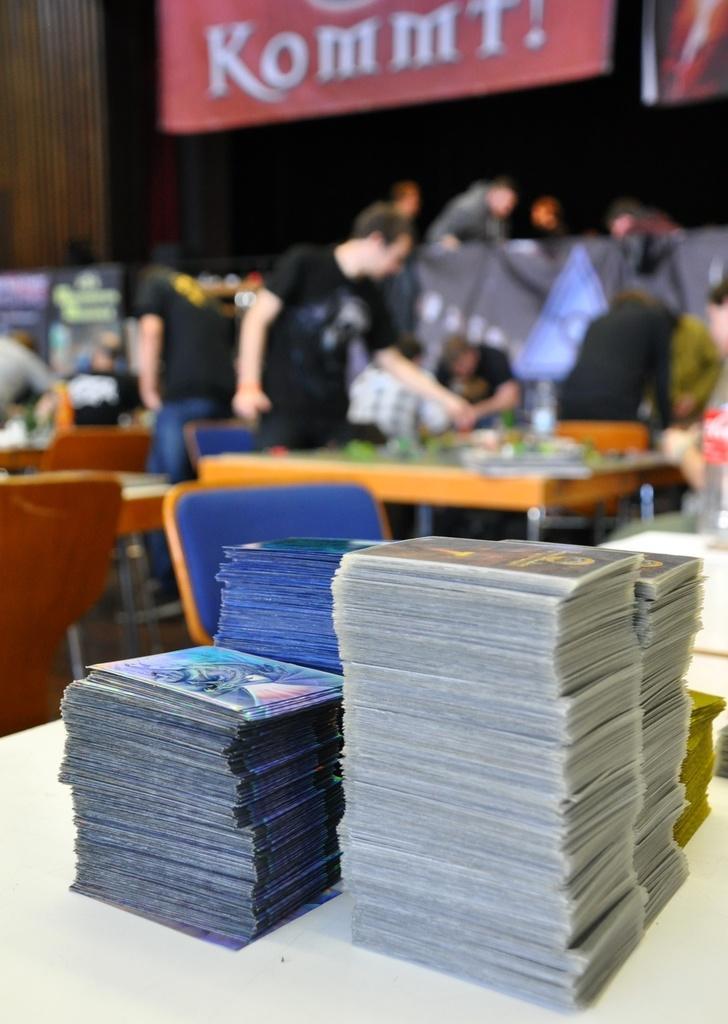In one or two sentences, can you explain what this image depicts? In this image I see a table over here on which there are number of books and I see a chair over here and I see that it is blurred in the background and I see few people and I see few tables and chairs and I see a red color banner over here on which there is a word written and it is a bit dark over here. 